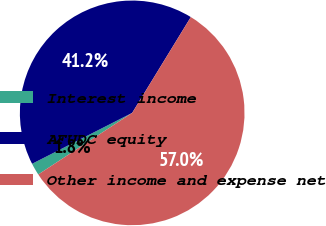Convert chart to OTSL. <chart><loc_0><loc_0><loc_500><loc_500><pie_chart><fcel>Interest income<fcel>AFUDC equity<fcel>Other income and expense net<nl><fcel>1.75%<fcel>41.23%<fcel>57.02%<nl></chart> 